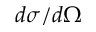<formula> <loc_0><loc_0><loc_500><loc_500>d \sigma / d \Omega</formula> 